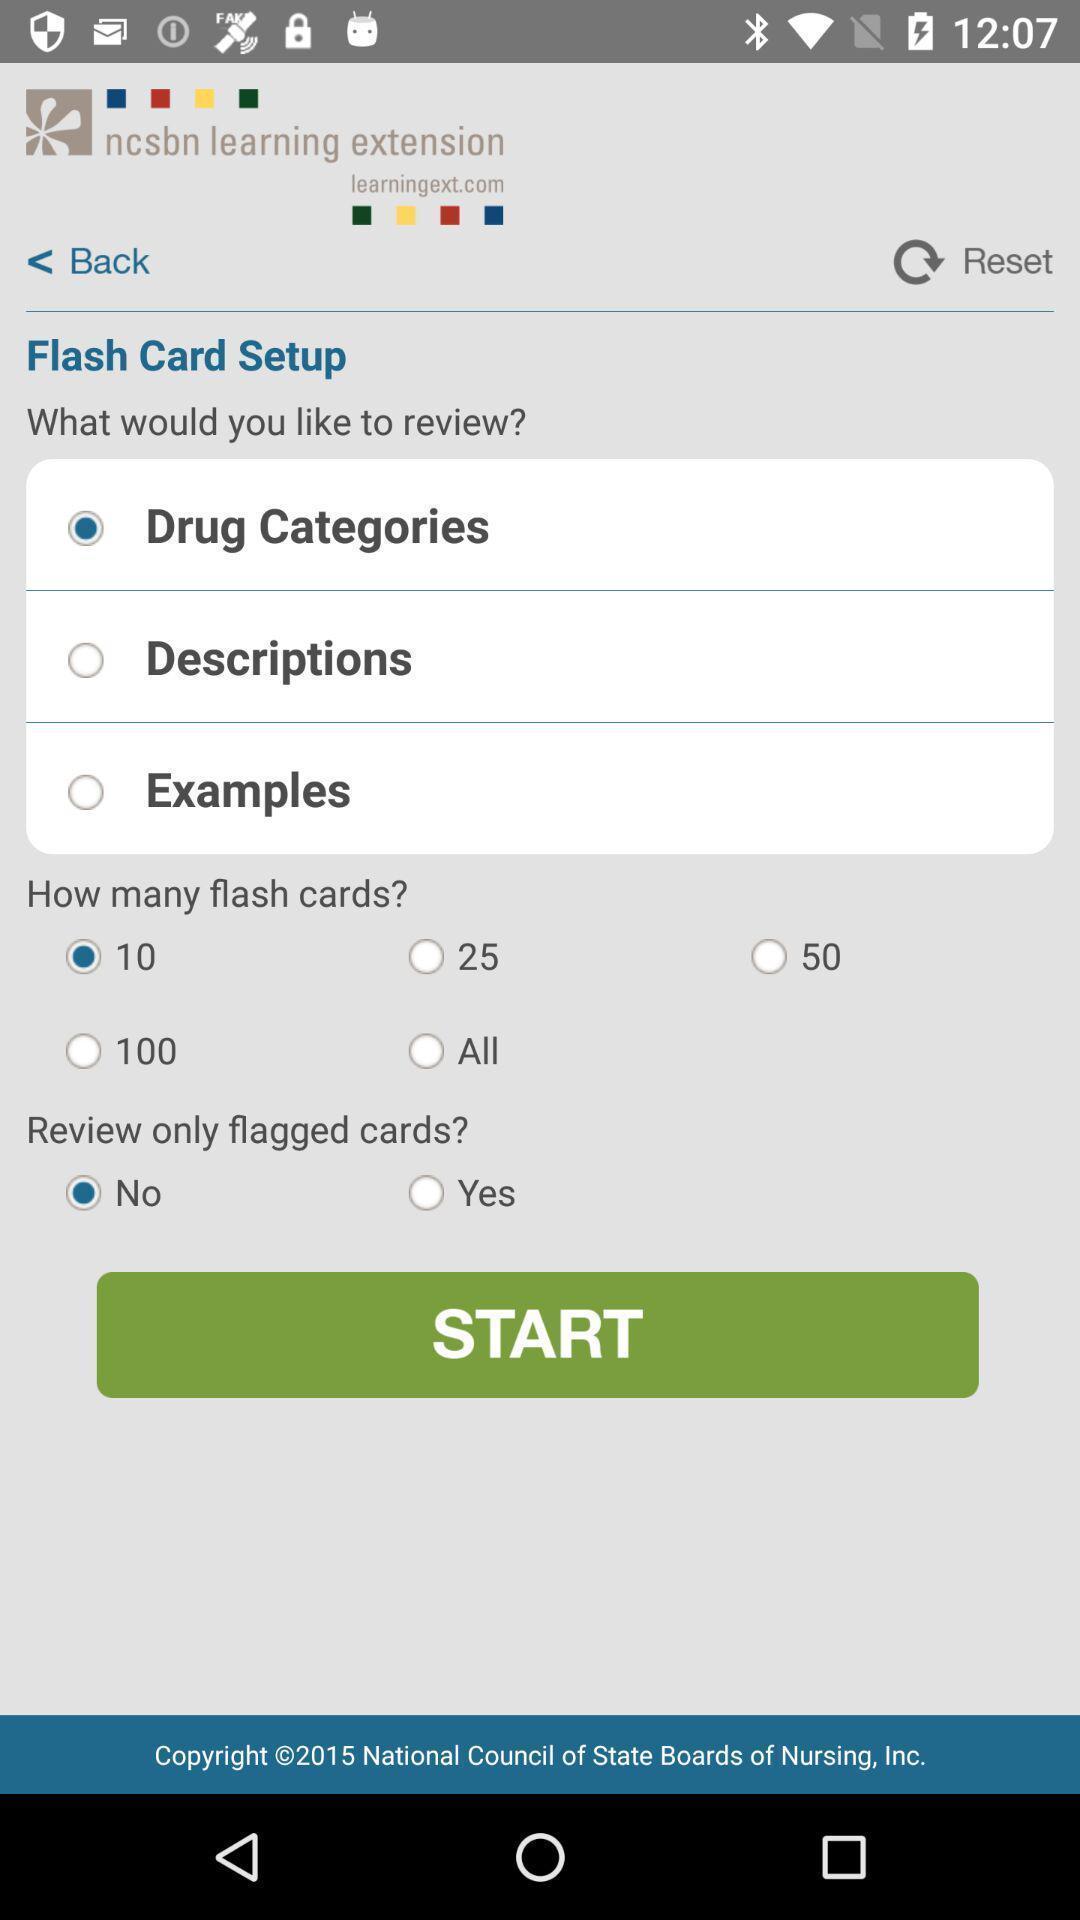What details can you identify in this image? Screen page of a learning app. 